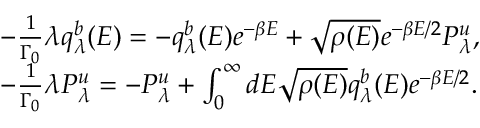Convert formula to latex. <formula><loc_0><loc_0><loc_500><loc_500>\begin{array} { r l } & { - \frac { 1 } { \Gamma _ { 0 } } \lambda q _ { \lambda } ^ { b } ( E ) = - q _ { \lambda } ^ { b } ( E ) e ^ { - \beta E } + \sqrt { \rho ( E ) } e ^ { - \beta E / 2 } P _ { \lambda } ^ { u } , } \\ & { - \frac { 1 } { \Gamma _ { 0 } } \lambda P _ { \lambda } ^ { u } = - P _ { \lambda } ^ { u } + \int _ { 0 } ^ { \infty } d E \sqrt { \rho ( E ) } q _ { \lambda } ^ { b } ( E ) e ^ { - \beta E / 2 } . } \end{array}</formula> 